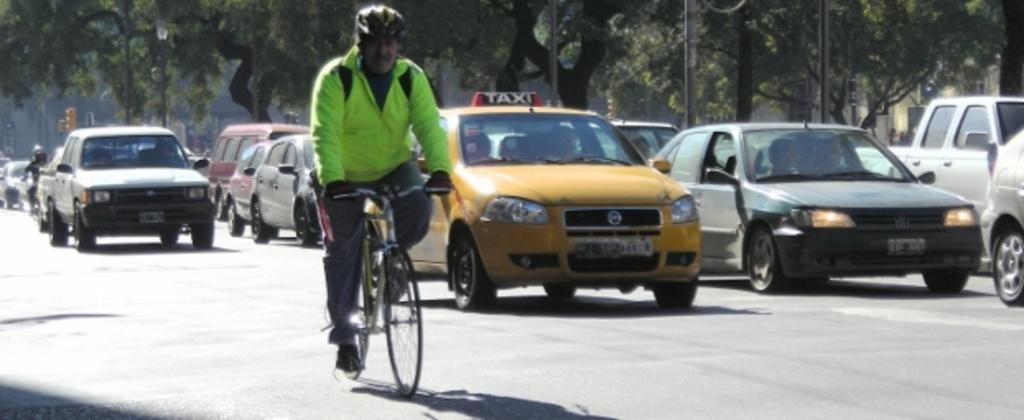<image>
Relay a brief, clear account of the picture shown. a taxi cab with the word taxi at the top 